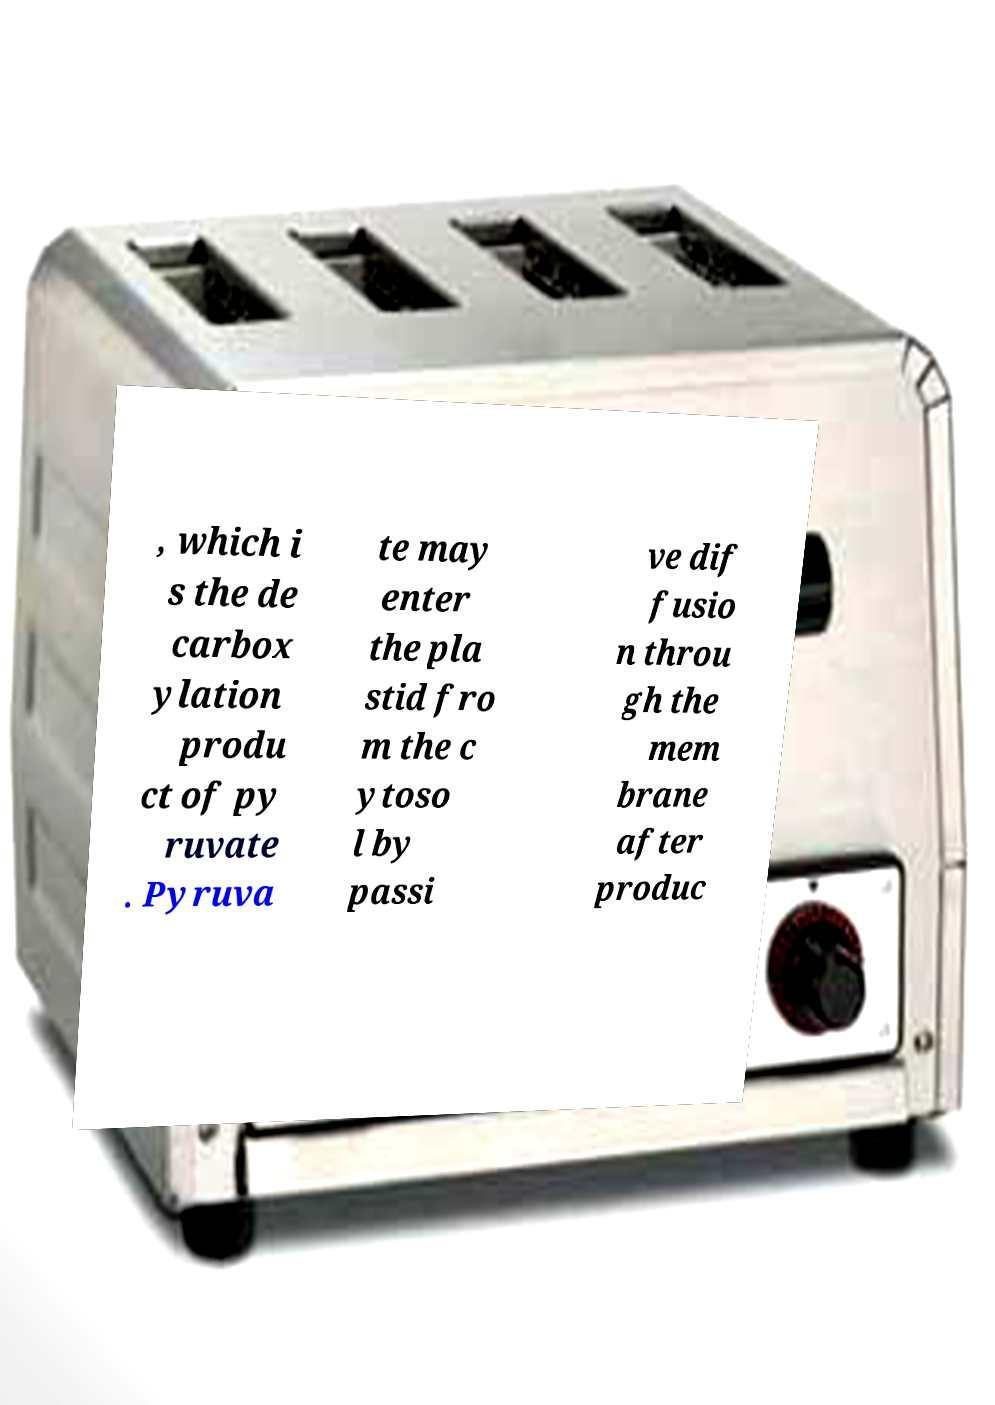Could you extract and type out the text from this image? , which i s the de carbox ylation produ ct of py ruvate . Pyruva te may enter the pla stid fro m the c ytoso l by passi ve dif fusio n throu gh the mem brane after produc 